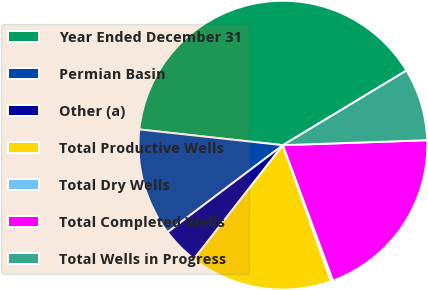Convert chart. <chart><loc_0><loc_0><loc_500><loc_500><pie_chart><fcel>Year Ended December 31<fcel>Permian Basin<fcel>Other (a)<fcel>Total Productive Wells<fcel>Total Dry Wells<fcel>Total Completed Wells<fcel>Total Wells in Progress<nl><fcel>39.61%<fcel>12.03%<fcel>4.16%<fcel>15.97%<fcel>0.22%<fcel>19.91%<fcel>8.1%<nl></chart> 